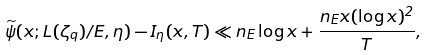Convert formula to latex. <formula><loc_0><loc_0><loc_500><loc_500>\widetilde { \psi } ( x ; L ( \zeta _ { q } ) / E , \eta ) - I _ { \eta } ( x , T ) \ll n _ { E } \log x + \frac { n _ { E } x ( \log x ) ^ { 2 } } { T } ,</formula> 